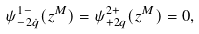Convert formula to latex. <formula><loc_0><loc_0><loc_500><loc_500>\psi ^ { 1 - } _ { - 2 \dot { q } } ( z ^ { M } ) = \psi ^ { 2 + } _ { + 2 q } ( z ^ { M } ) = 0 ,</formula> 